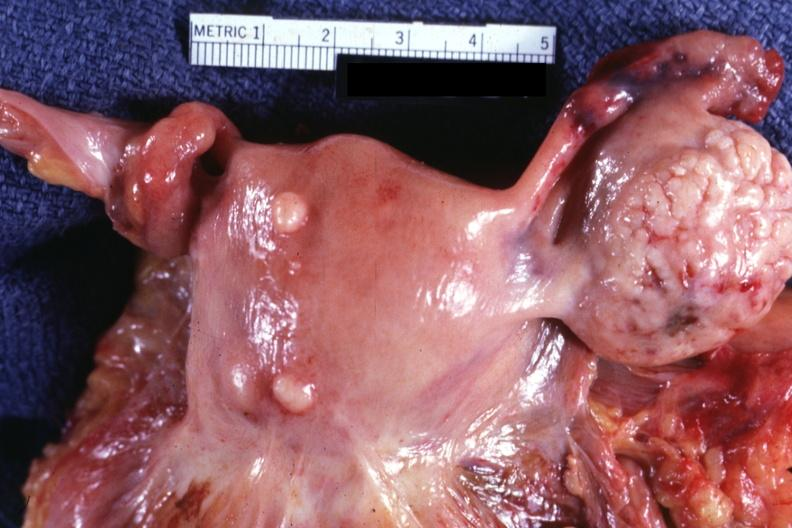what represent?
Answer the question using a single word or phrase. A bulge 